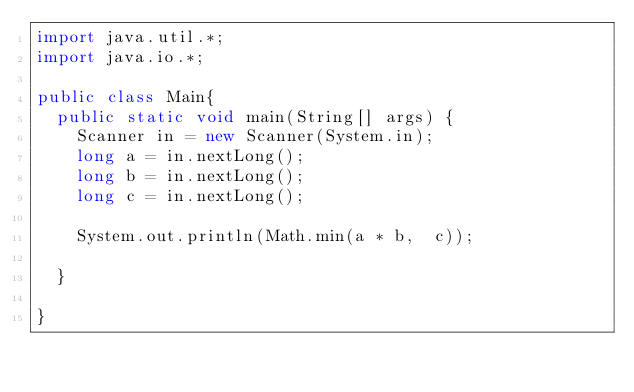<code> <loc_0><loc_0><loc_500><loc_500><_Java_>import java.util.*;
import java.io.*;

public class Main{
	public static void main(String[] args) {
		Scanner in = new Scanner(System.in);
		long a = in.nextLong();
		long b = in.nextLong();
		long c = in.nextLong();

		System.out.println(Math.min(a * b,  c));

	}

}</code> 